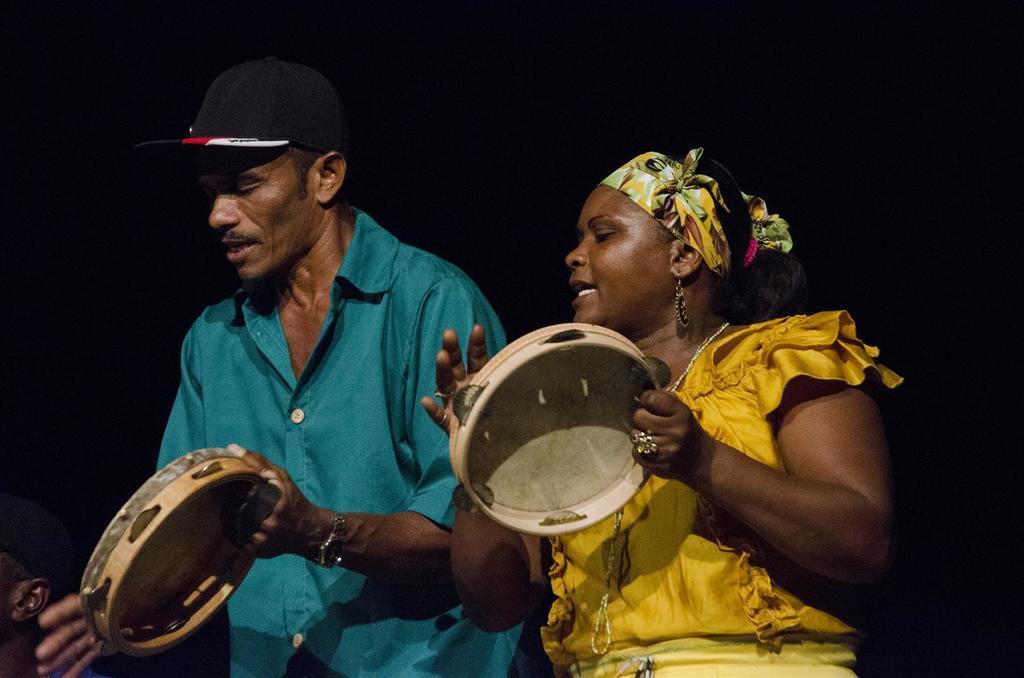Please provide a concise description of this image. In this image we can see this person wearing blue shirt and cap and this woman wearing yellow dress are playing musical instruments. Here we can see another person. The background of the image is dark. 